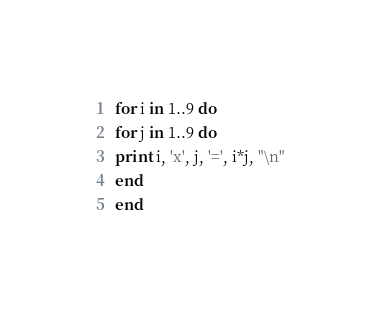<code> <loc_0><loc_0><loc_500><loc_500><_Ruby_>for i in 1..9 do
for j in 1..9 do
print i, 'x', j, '=', i*j, "\n"
end
end</code> 